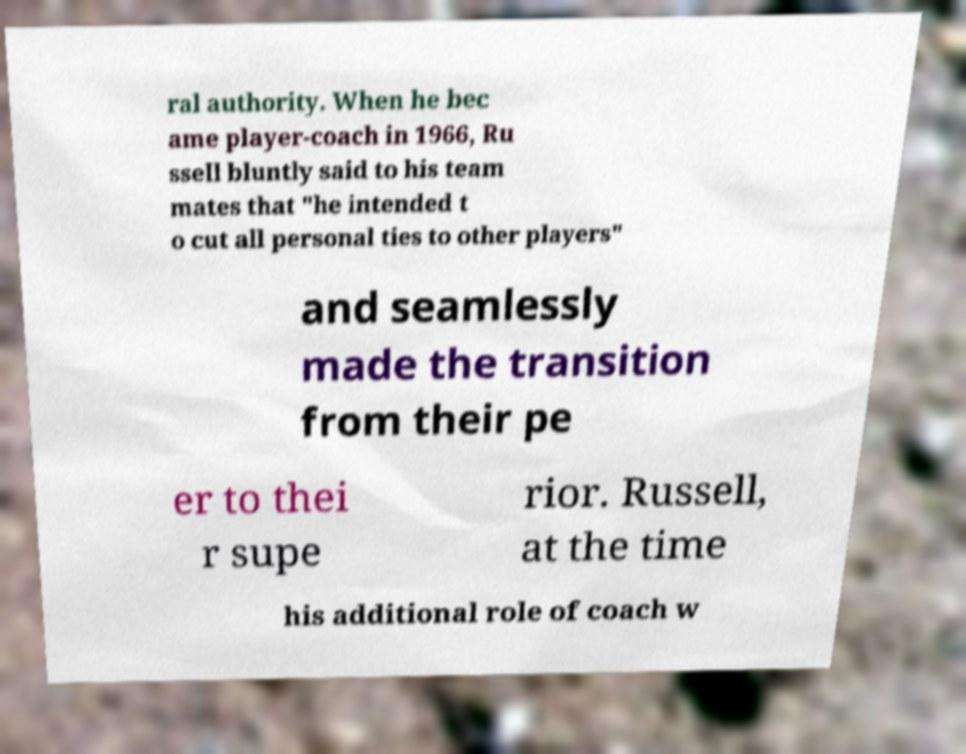Can you read and provide the text displayed in the image?This photo seems to have some interesting text. Can you extract and type it out for me? ral authority. When he bec ame player-coach in 1966, Ru ssell bluntly said to his team mates that "he intended t o cut all personal ties to other players" and seamlessly made the transition from their pe er to thei r supe rior. Russell, at the time his additional role of coach w 